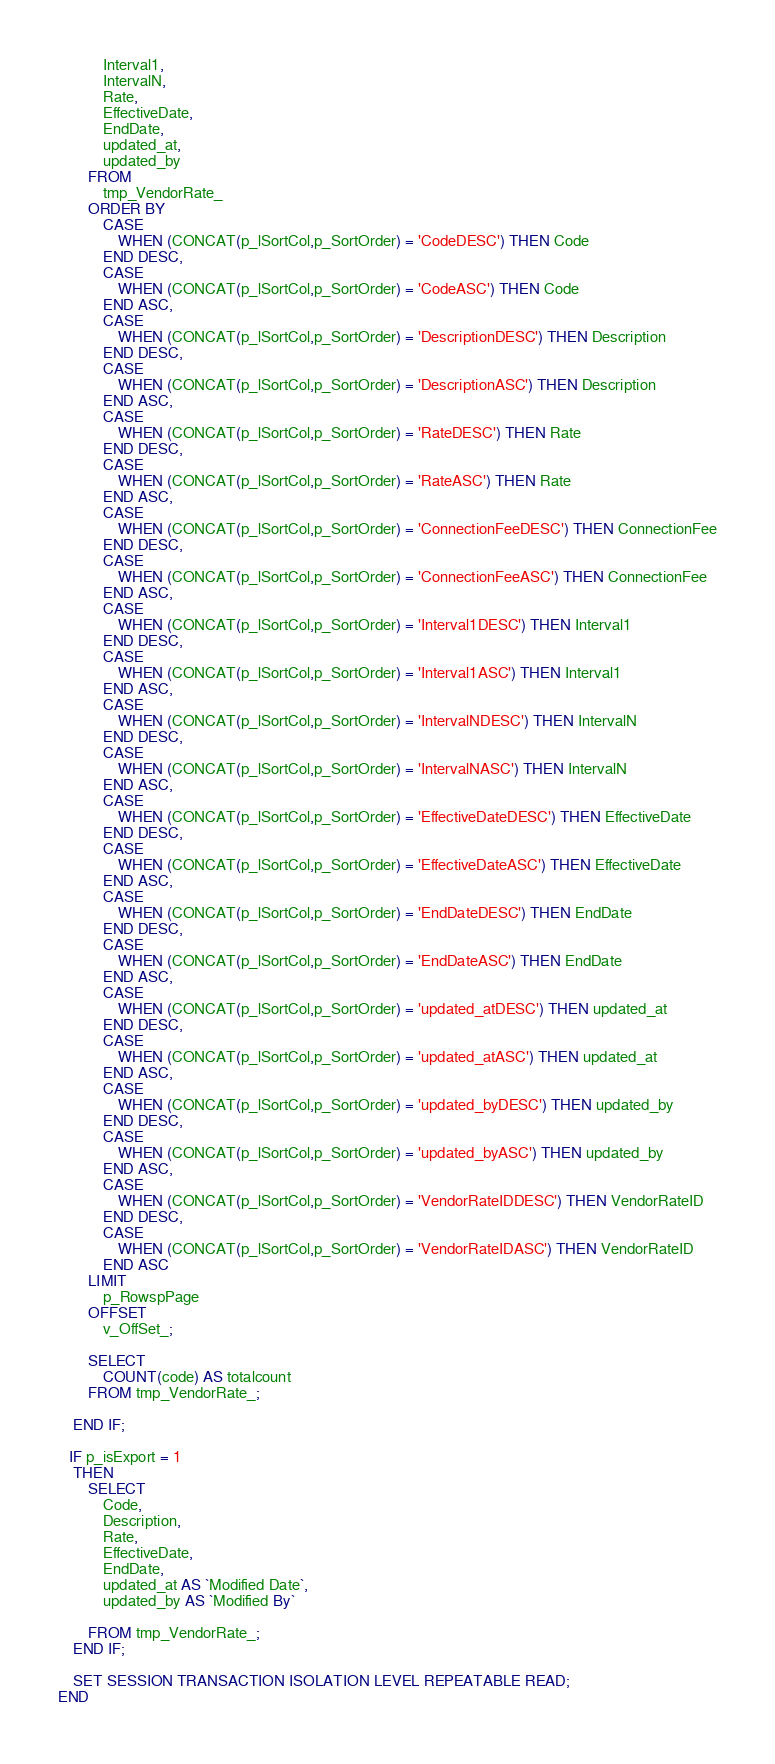Convert code to text. <code><loc_0><loc_0><loc_500><loc_500><_SQL_>			Interval1,
			IntervalN,
			Rate,
			EffectiveDate,
			EndDate,
			updated_at,
			updated_by
		FROM  
			tmp_VendorRate_
		ORDER BY 
			CASE
				WHEN (CONCAT(p_lSortCol,p_SortOrder) = 'CodeDESC') THEN Code
			END DESC,
			CASE
				WHEN (CONCAT(p_lSortCol,p_SortOrder) = 'CodeASC') THEN Code
			END ASC,
			CASE
				WHEN (CONCAT(p_lSortCol,p_SortOrder) = 'DescriptionDESC') THEN Description
			END DESC,
			CASE
				WHEN (CONCAT(p_lSortCol,p_SortOrder) = 'DescriptionASC') THEN Description
			END ASC,
			CASE
				WHEN (CONCAT(p_lSortCol,p_SortOrder) = 'RateDESC') THEN Rate
			END DESC,
			CASE
				WHEN (CONCAT(p_lSortCol,p_SortOrder) = 'RateASC') THEN Rate
			END ASC,
			CASE
				WHEN (CONCAT(p_lSortCol,p_SortOrder) = 'ConnectionFeeDESC') THEN ConnectionFee
			END DESC,
			CASE
				WHEN (CONCAT(p_lSortCol,p_SortOrder) = 'ConnectionFeeASC') THEN ConnectionFee
			END ASC,
			CASE
				WHEN (CONCAT(p_lSortCol,p_SortOrder) = 'Interval1DESC') THEN Interval1
			END DESC,
			CASE
				WHEN (CONCAT(p_lSortCol,p_SortOrder) = 'Interval1ASC') THEN Interval1
			END ASC,
			CASE
				WHEN (CONCAT(p_lSortCol,p_SortOrder) = 'IntervalNDESC') THEN IntervalN
			END DESC,
			CASE
				WHEN (CONCAT(p_lSortCol,p_SortOrder) = 'IntervalNASC') THEN IntervalN
			END ASC,
			CASE
				WHEN (CONCAT(p_lSortCol,p_SortOrder) = 'EffectiveDateDESC') THEN EffectiveDate
			END DESC,
			CASE
				WHEN (CONCAT(p_lSortCol,p_SortOrder) = 'EffectiveDateASC') THEN EffectiveDate
			END ASC,
			CASE
				WHEN (CONCAT(p_lSortCol,p_SortOrder) = 'EndDateDESC') THEN EndDate
			END DESC,
			CASE
				WHEN (CONCAT(p_lSortCol,p_SortOrder) = 'EndDateASC') THEN EndDate
			END ASC,
			CASE
				WHEN (CONCAT(p_lSortCol,p_SortOrder) = 'updated_atDESC') THEN updated_at
			END DESC,
			CASE
				WHEN (CONCAT(p_lSortCol,p_SortOrder) = 'updated_atASC') THEN updated_at
			END ASC,
			CASE
				WHEN (CONCAT(p_lSortCol,p_SortOrder) = 'updated_byDESC') THEN updated_by
			END DESC,
			CASE
				WHEN (CONCAT(p_lSortCol,p_SortOrder) = 'updated_byASC') THEN updated_by
			END ASC,
			CASE
				WHEN (CONCAT(p_lSortCol,p_SortOrder) = 'VendorRateIDDESC') THEN VendorRateID
			END DESC,
			CASE
				WHEN (CONCAT(p_lSortCol,p_SortOrder) = 'VendorRateIDASC') THEN VendorRateID
			END ASC
		LIMIT 
			p_RowspPage 
		OFFSET 
			v_OffSet_;

		SELECT
			COUNT(code) AS totalcount
		FROM tmp_VendorRate_;
	
	END IF;
	
   IF p_isExport = 1
	THEN
		SELECT
			Code,
			Description,
			Rate,
			EffectiveDate,
			EndDate,
			updated_at AS `Modified Date`,
			updated_by AS `Modified By`

		FROM tmp_VendorRate_;
	END IF;
	
	SET SESSION TRANSACTION ISOLATION LEVEL REPEATABLE READ;
END</code> 